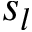Convert formula to latex. <formula><loc_0><loc_0><loc_500><loc_500>s _ { l }</formula> 